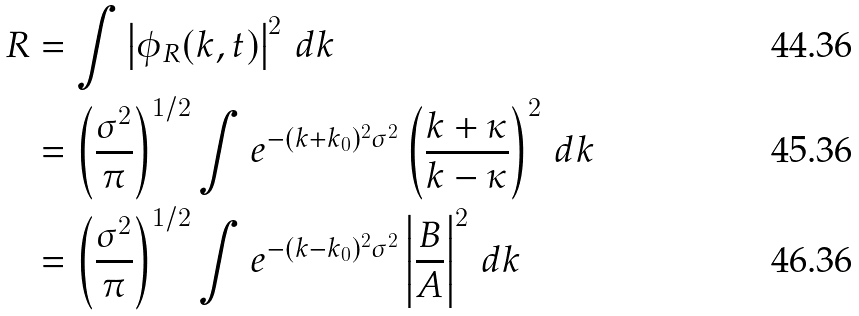Convert formula to latex. <formula><loc_0><loc_0><loc_500><loc_500>R & = \int \left | \phi _ { R } ( k , t ) \right | ^ { 2 } \, d k \\ & = \left ( \frac { \sigma ^ { 2 } } { \pi } \right ) ^ { 1 / 2 } \int e ^ { - ( k + k _ { 0 } ) ^ { 2 } \sigma ^ { 2 } } \left ( \frac { k + \kappa } { k - \kappa } \right ) ^ { 2 } \, d k \\ & = \left ( \frac { \sigma ^ { 2 } } { \pi } \right ) ^ { 1 / 2 } \int e ^ { - ( k - k _ { 0 } ) ^ { 2 } \sigma ^ { 2 } } \left | \frac { B } { A } \right | ^ { 2 } \, d k</formula> 